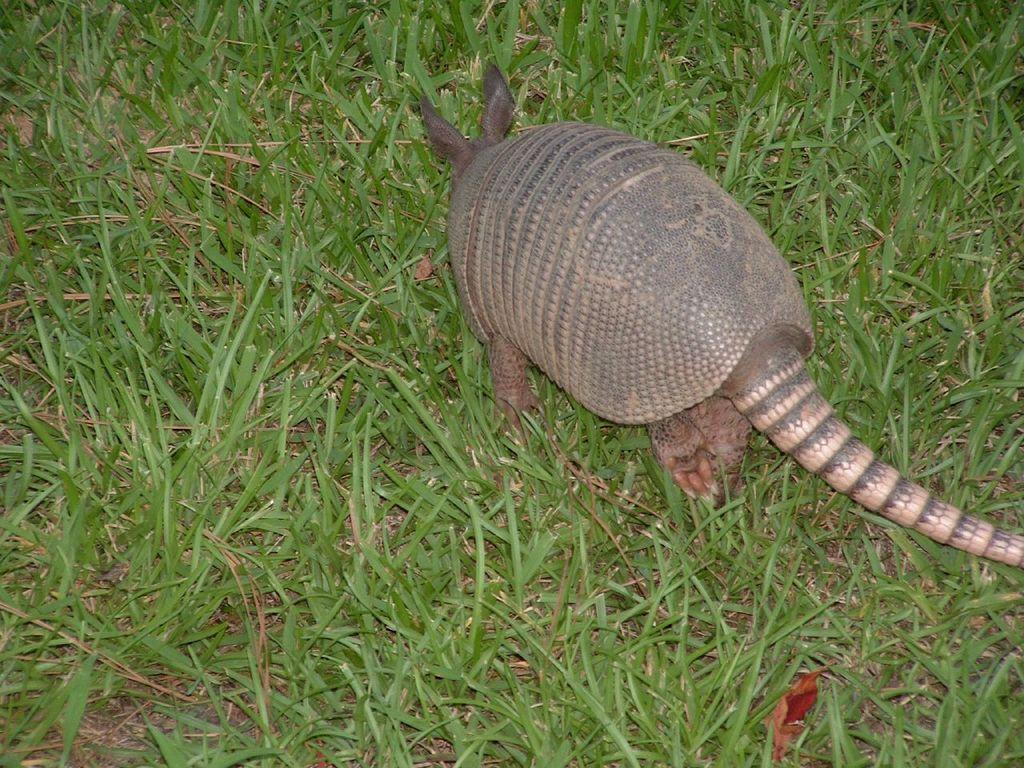What type of creature is present in the image? There is an animal in the image. What is the animal doing in the image? The animal is walking on the grass. What type of crime is being committed by the animal in the image? There is no crime being committed by the animal in the image; it is simply walking on the grass. How many people are present in the crowd in the image? There is no crowd present in the image; it only features an animal walking on the grass. 